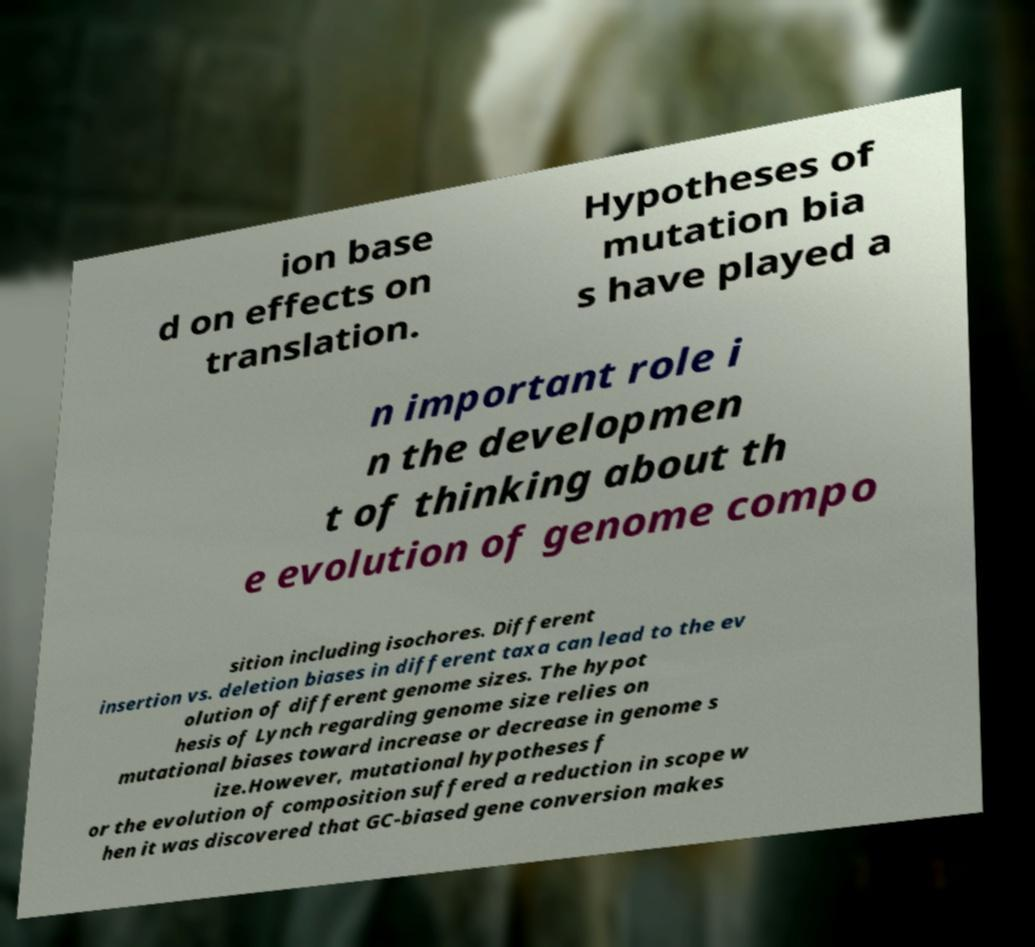Could you assist in decoding the text presented in this image and type it out clearly? ion base d on effects on translation. Hypotheses of mutation bia s have played a n important role i n the developmen t of thinking about th e evolution of genome compo sition including isochores. Different insertion vs. deletion biases in different taxa can lead to the ev olution of different genome sizes. The hypot hesis of Lynch regarding genome size relies on mutational biases toward increase or decrease in genome s ize.However, mutational hypotheses f or the evolution of composition suffered a reduction in scope w hen it was discovered that GC-biased gene conversion makes 